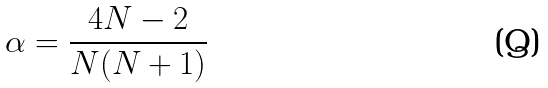<formula> <loc_0><loc_0><loc_500><loc_500>\alpha = \frac { 4 N - 2 } { N ( N + 1 ) }</formula> 